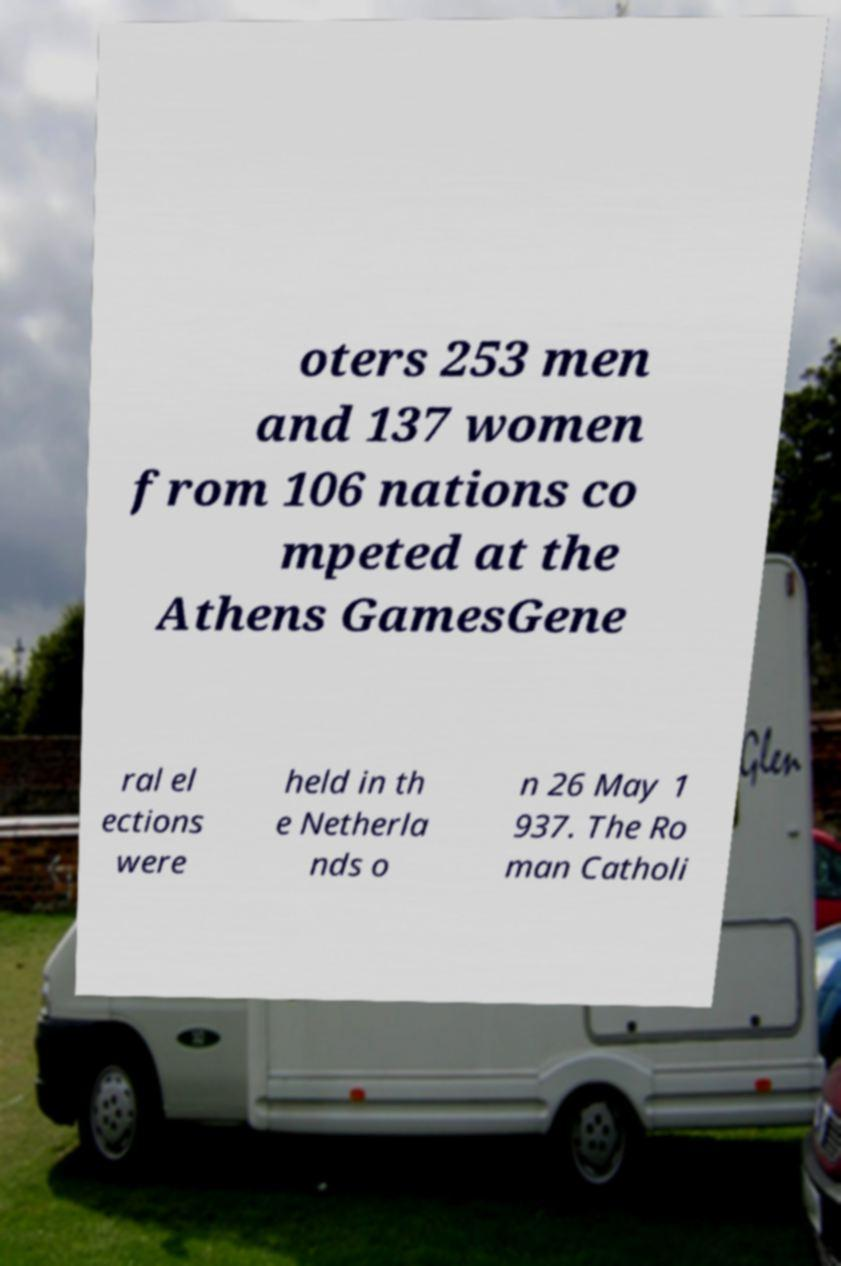Please identify and transcribe the text found in this image. oters 253 men and 137 women from 106 nations co mpeted at the Athens GamesGene ral el ections were held in th e Netherla nds o n 26 May 1 937. The Ro man Catholi 